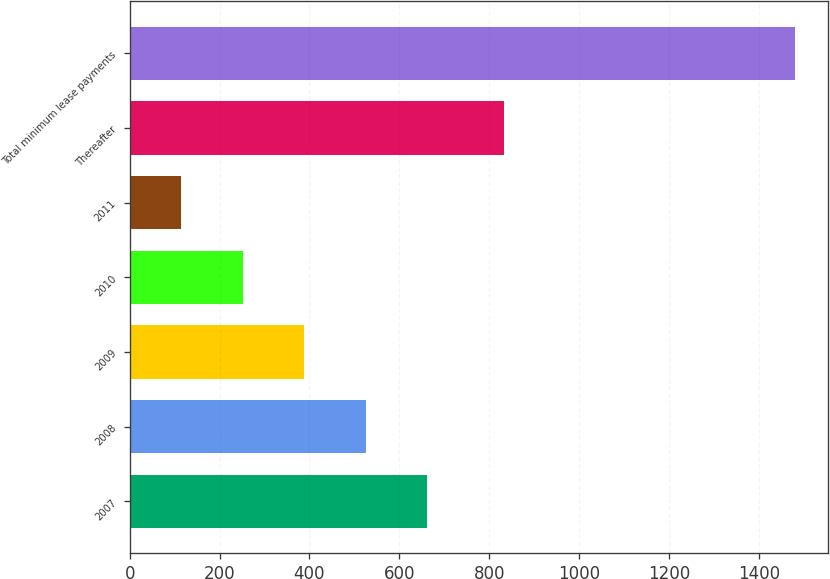Convert chart to OTSL. <chart><loc_0><loc_0><loc_500><loc_500><bar_chart><fcel>2007<fcel>2008<fcel>2009<fcel>2010<fcel>2011<fcel>Thereafter<fcel>Total minimum lease payments<nl><fcel>661.4<fcel>524.8<fcel>388.2<fcel>251.6<fcel>115<fcel>833<fcel>1481<nl></chart> 